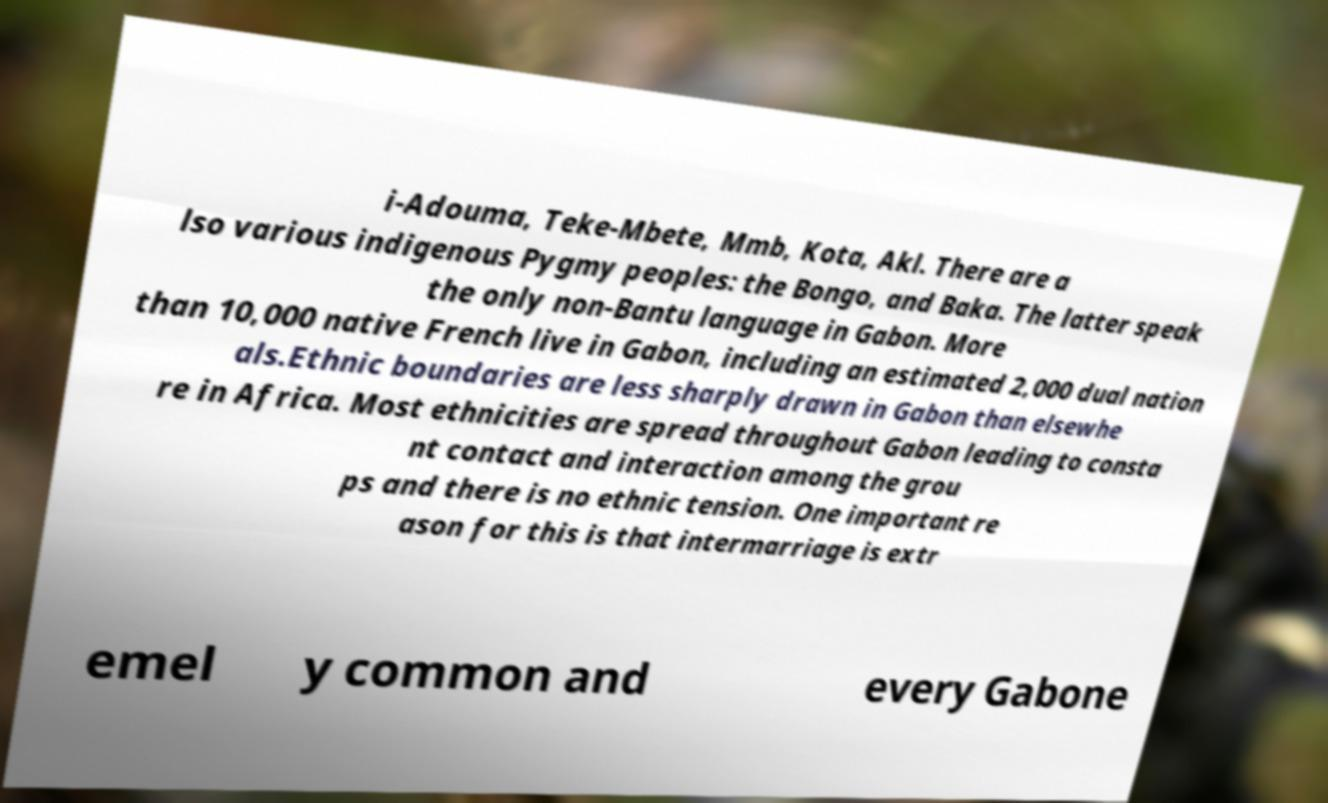Please read and relay the text visible in this image. What does it say? i-Adouma, Teke-Mbete, Mmb, Kota, Akl. There are a lso various indigenous Pygmy peoples: the Bongo, and Baka. The latter speak the only non-Bantu language in Gabon. More than 10,000 native French live in Gabon, including an estimated 2,000 dual nation als.Ethnic boundaries are less sharply drawn in Gabon than elsewhe re in Africa. Most ethnicities are spread throughout Gabon leading to consta nt contact and interaction among the grou ps and there is no ethnic tension. One important re ason for this is that intermarriage is extr emel y common and every Gabone 